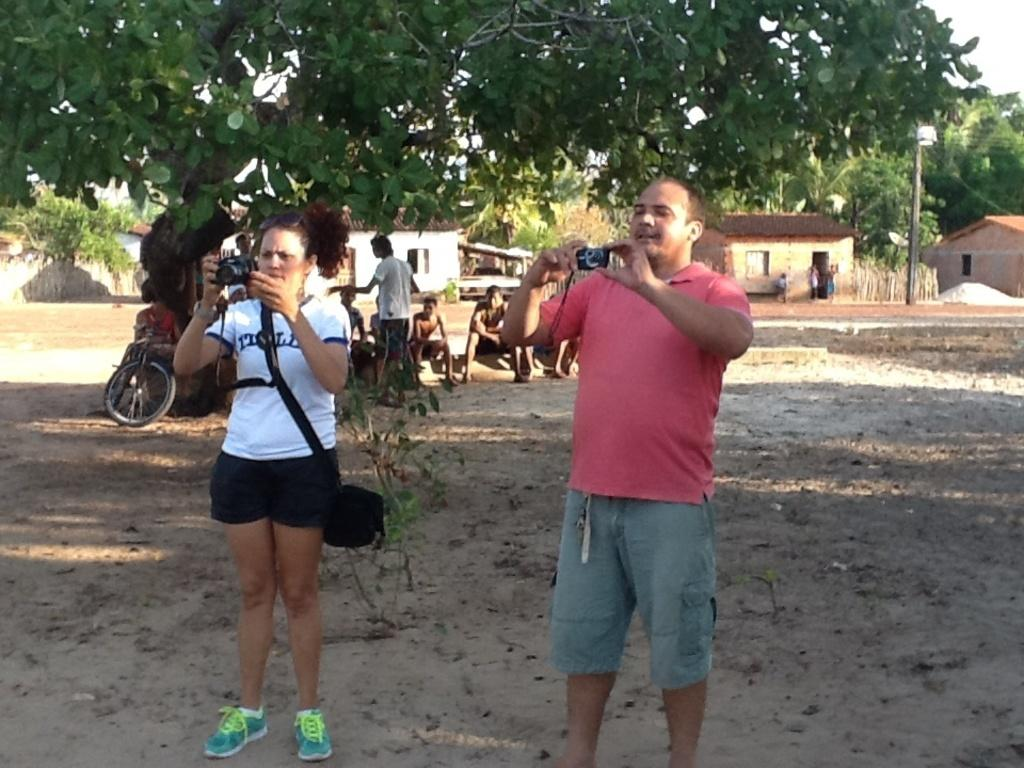How many people are in the image? There is a group of people in the image, but the exact number is not specified. What is the position of the people in the image? The people are on the ground in the image. What can be seen in the background of the image? There are houses, trees, and the sky visible in the background of the image. What type of popcorn is being served to the people in the image? There is no popcorn present in the image; it features a group of people on the ground with houses, trees, and the sky in the background. 